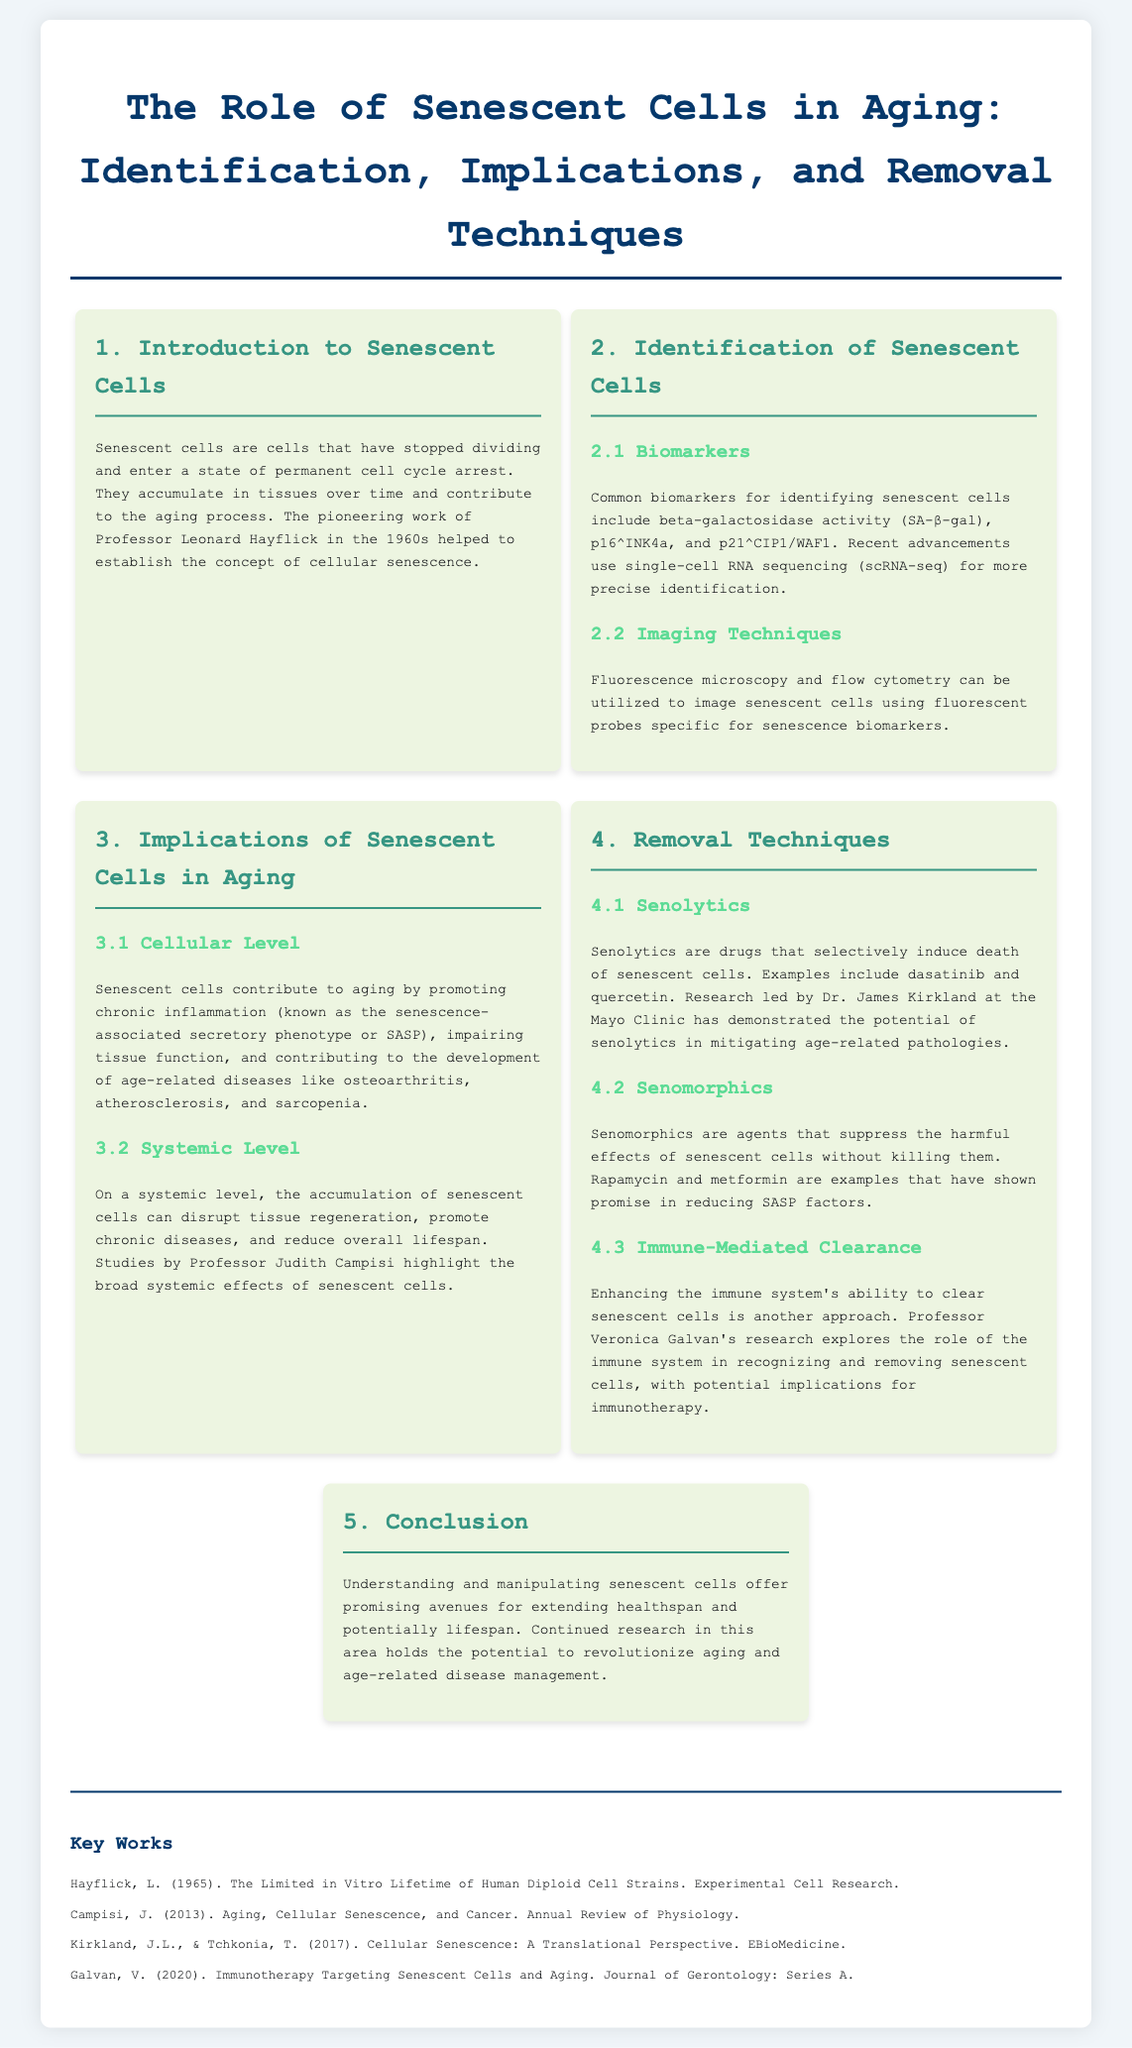What is the first step in the infographic? The first step introduces senescent cells and their role in aging.
Answer: Introduction to Senescent Cells What is SA-β-gal? SA-β-gal is a common biomarker used for identifying senescent cells.
Answer: beta-galactosidase activity Who conducted pioneering work on cellular senescence? Professor Leonard Hayflick established the concept of cellular senescence.
Answer: Professor Leonard Hayflick Which diseases are associated with senescent cells? Senescent cells contribute to diseases like osteoarthritis, atherosclerosis, and sarcopenia.
Answer: osteoarthritis, atherosclerosis, sarcopenia What are senolytics? Senolytics are drugs that selectively induce death of senescent cells.
Answer: drugs Which research refers to the systemic effects of senescent cells? Professor Judith Campisi's studies highlight the broad systemic effects of senescent cells.
Answer: Professor Judith Campisi What are senomorphics used for? Senomorphics suppress harmful effects of senescent cells without killing them.
Answer: suppress harmful effects Who is exploring immune-mediated clearance of senescent cells? Professor Veronica Galvan's research focuses on the immune system's role in this process.
Answer: Professor Veronica Galvan What is the ultimate goal of understanding senescent cells? The goal is to extend healthspan and potentially lifespan.
Answer: extend healthspan and potentially lifespan 